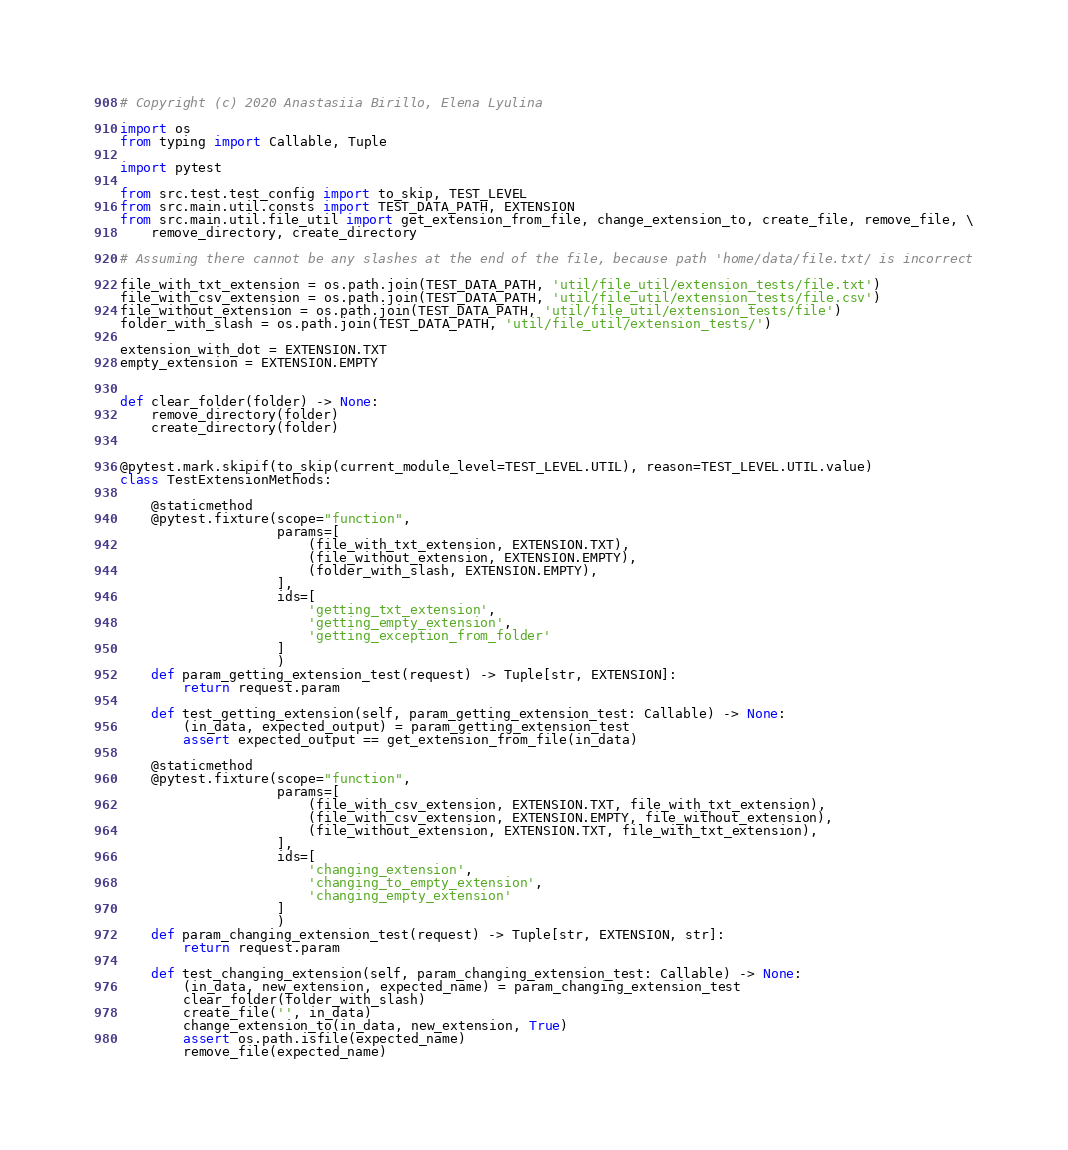Convert code to text. <code><loc_0><loc_0><loc_500><loc_500><_Python_># Copyright (c) 2020 Anastasiia Birillo, Elena Lyulina

import os
from typing import Callable, Tuple

import pytest

from src.test.test_config import to_skip, TEST_LEVEL
from src.main.util.consts import TEST_DATA_PATH, EXTENSION
from src.main.util.file_util import get_extension_from_file, change_extension_to, create_file, remove_file, \
    remove_directory, create_directory

# Assuming there cannot be any slashes at the end of the file, because path 'home/data/file.txt/ is incorrect

file_with_txt_extension = os.path.join(TEST_DATA_PATH, 'util/file_util/extension_tests/file.txt')
file_with_csv_extension = os.path.join(TEST_DATA_PATH, 'util/file_util/extension_tests/file.csv')
file_without_extension = os.path.join(TEST_DATA_PATH, 'util/file_util/extension_tests/file')
folder_with_slash = os.path.join(TEST_DATA_PATH, 'util/file_util/extension_tests/')

extension_with_dot = EXTENSION.TXT
empty_extension = EXTENSION.EMPTY


def clear_folder(folder) -> None:
    remove_directory(folder)
    create_directory(folder)


@pytest.mark.skipif(to_skip(current_module_level=TEST_LEVEL.UTIL), reason=TEST_LEVEL.UTIL.value)
class TestExtensionMethods:

    @staticmethod
    @pytest.fixture(scope="function",
                    params=[
                        (file_with_txt_extension, EXTENSION.TXT),
                        (file_without_extension, EXTENSION.EMPTY),
                        (folder_with_slash, EXTENSION.EMPTY),
                    ],
                    ids=[
                        'getting_txt_extension',
                        'getting_empty_extension',
                        'getting_exception_from_folder'
                    ]
                    )
    def param_getting_extension_test(request) -> Tuple[str, EXTENSION]:
        return request.param

    def test_getting_extension(self, param_getting_extension_test: Callable) -> None:
        (in_data, expected_output) = param_getting_extension_test
        assert expected_output == get_extension_from_file(in_data)

    @staticmethod
    @pytest.fixture(scope="function",
                    params=[
                        (file_with_csv_extension, EXTENSION.TXT, file_with_txt_extension),
                        (file_with_csv_extension, EXTENSION.EMPTY, file_without_extension),
                        (file_without_extension, EXTENSION.TXT, file_with_txt_extension),
                    ],
                    ids=[
                        'changing_extension',
                        'changing_to_empty_extension',
                        'changing_empty_extension'
                    ]
                    )
    def param_changing_extension_test(request) -> Tuple[str, EXTENSION, str]:
        return request.param

    def test_changing_extension(self, param_changing_extension_test: Callable) -> None:
        (in_data, new_extension, expected_name) = param_changing_extension_test
        clear_folder(folder_with_slash)
        create_file('', in_data)
        change_extension_to(in_data, new_extension, True)
        assert os.path.isfile(expected_name)
        remove_file(expected_name)
</code> 